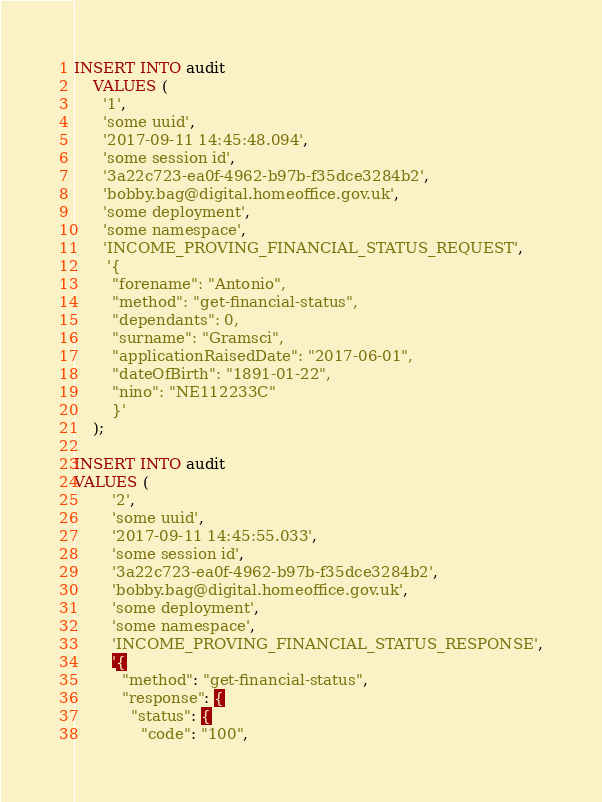Convert code to text. <code><loc_0><loc_0><loc_500><loc_500><_SQL_>INSERT INTO audit
    VALUES (
      '1',
      'some uuid',
      '2017-09-11 14:45:48.094',
      'some session id',
      '3a22c723-ea0f-4962-b97b-f35dce3284b2',
      'bobby.bag@digital.homeoffice.gov.uk',
      'some deployment',
      'some namespace',
      'INCOME_PROVING_FINANCIAL_STATUS_REQUEST',
       '{
        "forename": "Antonio",
        "method": "get-financial-status",
        "dependants": 0,
        "surname": "Gramsci",
        "applicationRaisedDate": "2017-06-01",
        "dateOfBirth": "1891-01-22",
        "nino": "NE112233C"
        }'
    );

INSERT INTO audit
VALUES (
        '2',
        'some uuid',
        '2017-09-11 14:45:55.033',
        'some session id',
        '3a22c723-ea0f-4962-b97b-f35dce3284b2',
        'bobby.bag@digital.homeoffice.gov.uk',
        'some deployment',
        'some namespace',
        'INCOME_PROVING_FINANCIAL_STATUS_RESPONSE',
        '{
          "method": "get-financial-status",
          "response": {
            "status": {
              "code": "100",</code> 